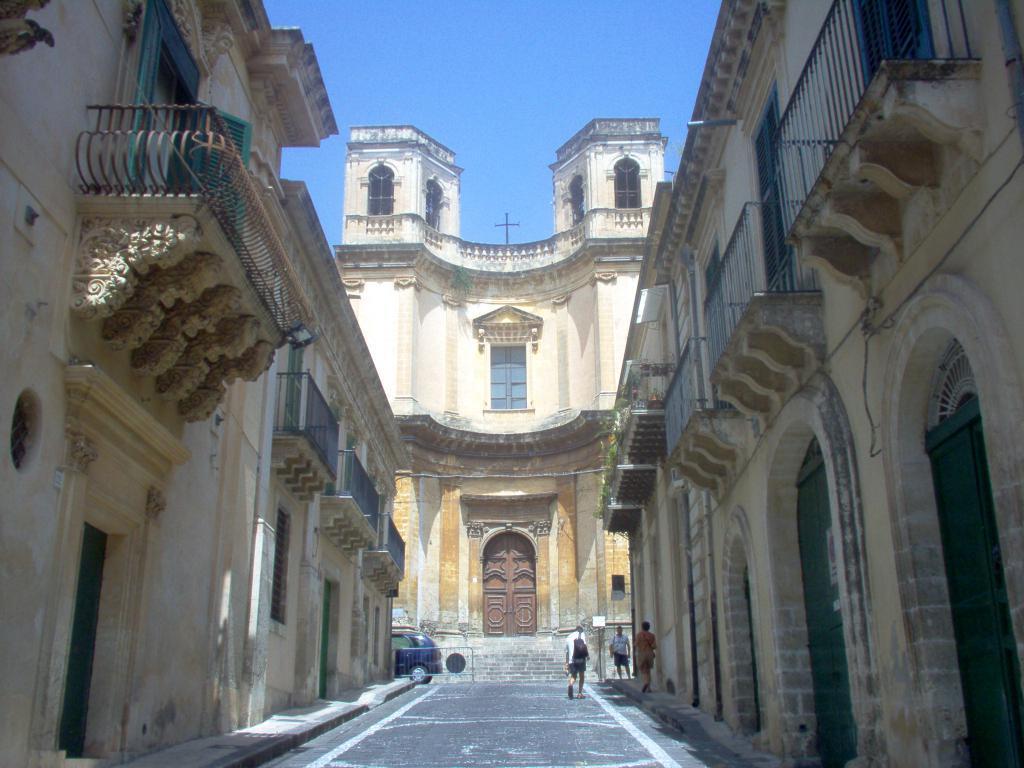Please provide a concise description of this image. In this picture we can see there are three people on the path and on the left side of the people there is a barrier and a vehicle on the road. Behind the people there are buildings and a sky. 